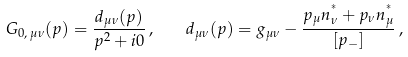Convert formula to latex. <formula><loc_0><loc_0><loc_500><loc_500>G _ { 0 , \, \mu \nu } ( p ) = \frac { d _ { \mu \nu } ( p ) } { p ^ { 2 } + i 0 } \, , \quad d _ { \mu \nu } ( p ) = g _ { \mu \nu } - \frac { p _ { \mu } n ^ { ^ { * } } _ { \nu } + p _ { \nu } n ^ { ^ { * } } _ { \mu } } { [ p _ { - } ] } \, ,</formula> 